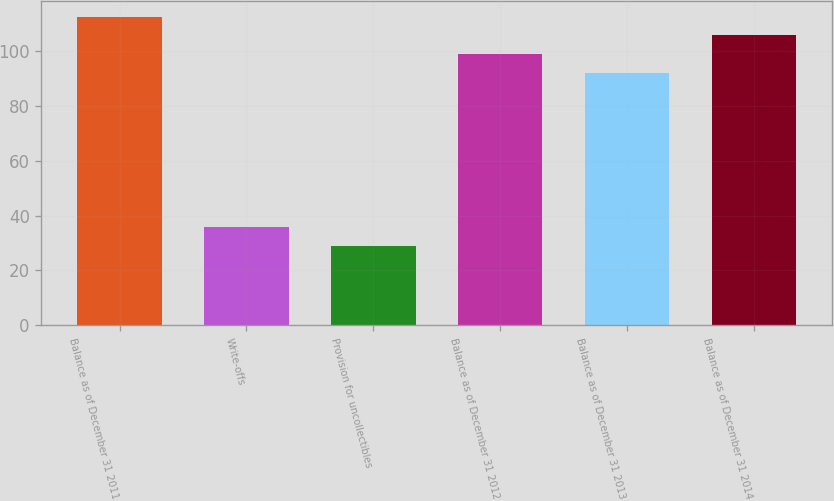Convert chart to OTSL. <chart><loc_0><loc_0><loc_500><loc_500><bar_chart><fcel>Balance as of December 31 2011<fcel>Write-offs<fcel>Provision for uncollectibles<fcel>Balance as of December 31 2012<fcel>Balance as of December 31 2013<fcel>Balance as of December 31 2014<nl><fcel>112.4<fcel>35.8<fcel>29<fcel>98.8<fcel>92<fcel>105.6<nl></chart> 